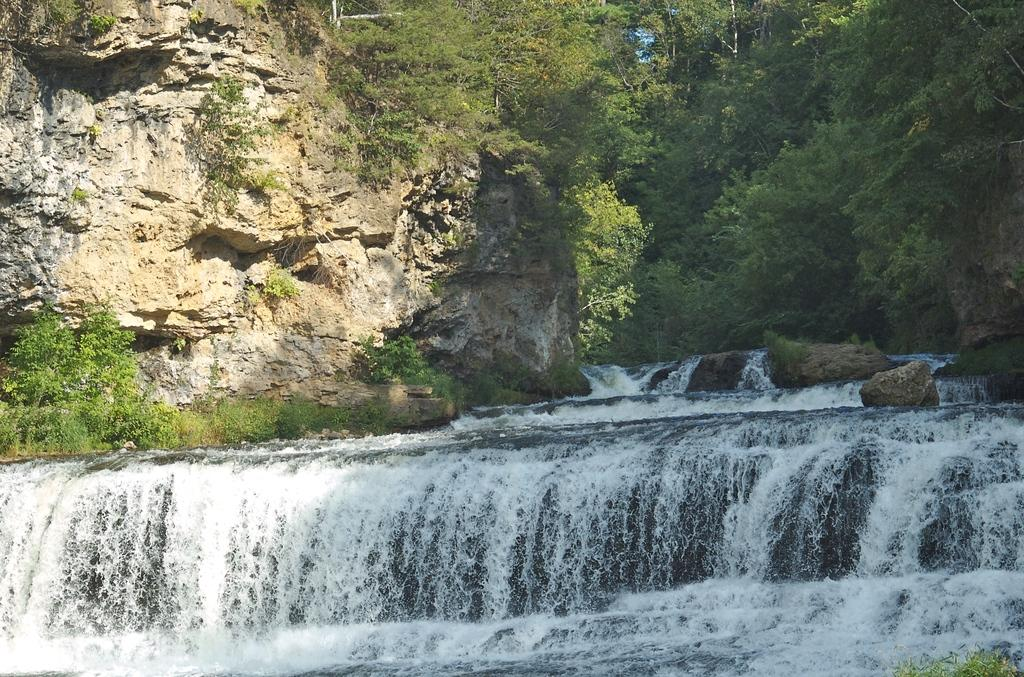What type of natural feature is present in the image? There is a flowing river in the image. What can be seen on the left side of the image? There is a hill on the left side of the image. What type of vegetation is present near the river in the image? There are many trees around the river in the image. What color is the knee of the person standing near the river in the image? There is no person present in the image, so it is not possible to determine the color of their knee. 